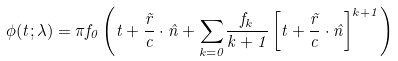Convert formula to latex. <formula><loc_0><loc_0><loc_500><loc_500>\phi ( t ; \lambda ) = \pi f _ { 0 } \left ( t + \frac { \vec { r } } { c } \cdot \hat { n } + \underset { k = 0 } \sum { \frac { f _ { k } } { k + 1 } } \left [ t + \frac { \vec { r } } { c } \cdot \hat { n } \right ] ^ { k + 1 } \right )</formula> 